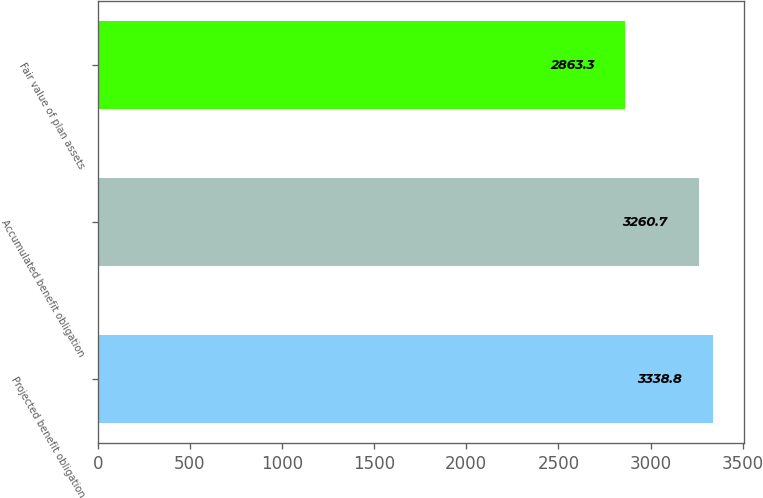Convert chart to OTSL. <chart><loc_0><loc_0><loc_500><loc_500><bar_chart><fcel>Projected benefit obligation<fcel>Accumulated benefit obligation<fcel>Fair value of plan assets<nl><fcel>3338.8<fcel>3260.7<fcel>2863.3<nl></chart> 